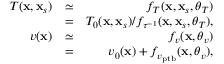<formula> <loc_0><loc_0><loc_500><loc_500>\begin{array} { r l r } { T ( x , x _ { s } ) } & { \simeq } & { f _ { T } ( x , x _ { s } , \theta _ { T } ) } \\ & { = } & { T _ { 0 } ( x , x _ { s } ) / f _ { \tau ^ { - 1 } } ( x , x _ { s } , \theta _ { T } ) , } \\ { v ( x ) } & { \simeq } & { f _ { v } ( x , \theta _ { v } ) } \\ & { = } & { v _ { 0 } ( x ) + f _ { v _ { p t b } } ( x , \theta _ { v } ) , } \end{array}</formula> 